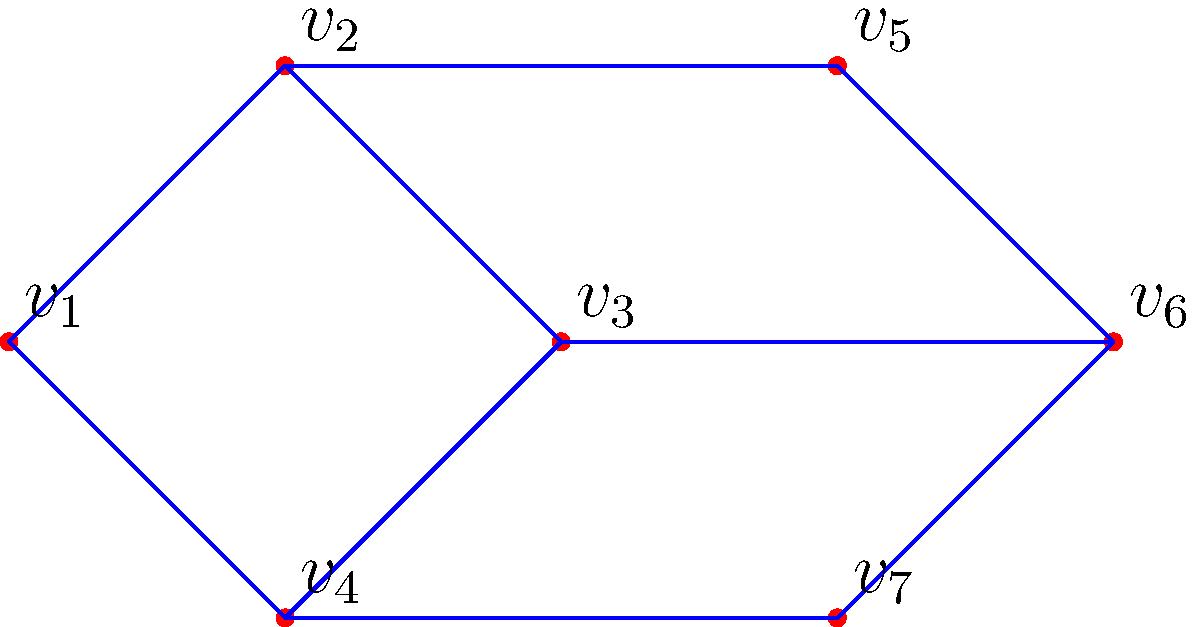In a television studio, each vertex represents a camera angle, and each edge represents a possible transition between angles. Given the graph above, what is the minimum number of camera transitions needed to cover all angles in the studio setup? To find the minimum number of camera transitions needed to cover all angles, we need to find the minimum number of edges that form a spanning tree in the graph. This is equivalent to finding a Minimum Spanning Tree (MST).

Step 1: Count the number of vertices (camera angles).
There are 7 vertices in the graph: $v_1$, $v_2$, $v_3$, $v_4$, $v_5$, $v_6$, and $v_7$.

Step 2: Recall that in a tree, the number of edges is always one less than the number of vertices.
Number of edges in MST = Number of vertices - 1

Step 3: Calculate the minimum number of transitions.
Minimum transitions = 7 - 1 = 6

Therefore, the minimum number of camera transitions needed to cover all angles in the studio setup is 6.
Answer: 6 transitions 